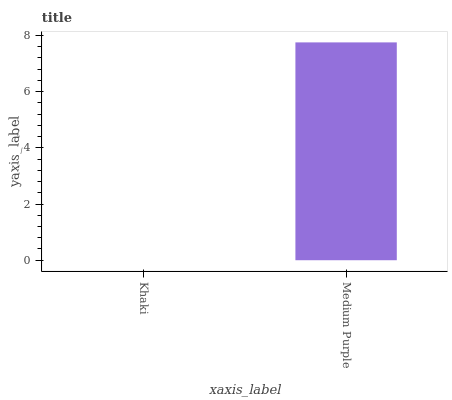Is Khaki the minimum?
Answer yes or no. Yes. Is Medium Purple the maximum?
Answer yes or no. Yes. Is Medium Purple the minimum?
Answer yes or no. No. Is Medium Purple greater than Khaki?
Answer yes or no. Yes. Is Khaki less than Medium Purple?
Answer yes or no. Yes. Is Khaki greater than Medium Purple?
Answer yes or no. No. Is Medium Purple less than Khaki?
Answer yes or no. No. Is Medium Purple the high median?
Answer yes or no. Yes. Is Khaki the low median?
Answer yes or no. Yes. Is Khaki the high median?
Answer yes or no. No. Is Medium Purple the low median?
Answer yes or no. No. 